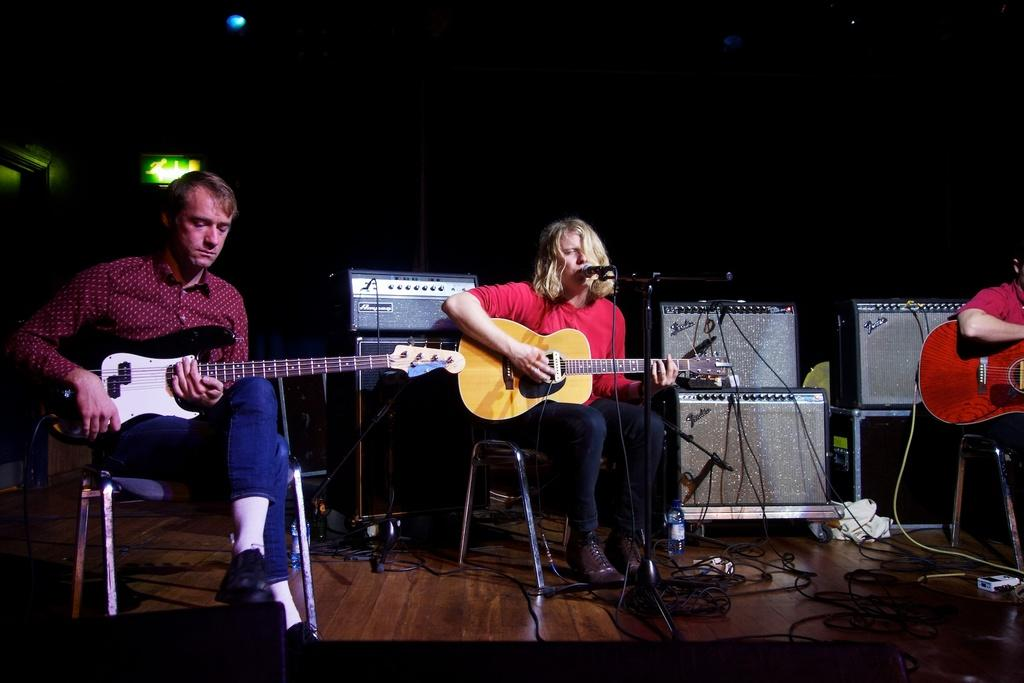How many people are in the image? There are three persons in the image. What are the persons doing in the image? The persons are sitting on chairs and playing guitar. What type of surface is visible beneath the persons? There is a floor visible in the image. What other objects can be seen in the image besides the persons? There are musical instruments in the image. What type of spark can be seen coming from the guitar in the image? There is no spark visible in the image; the persons are simply playing guitar. What type of bed is present in the image? There is no bed present in the image. 